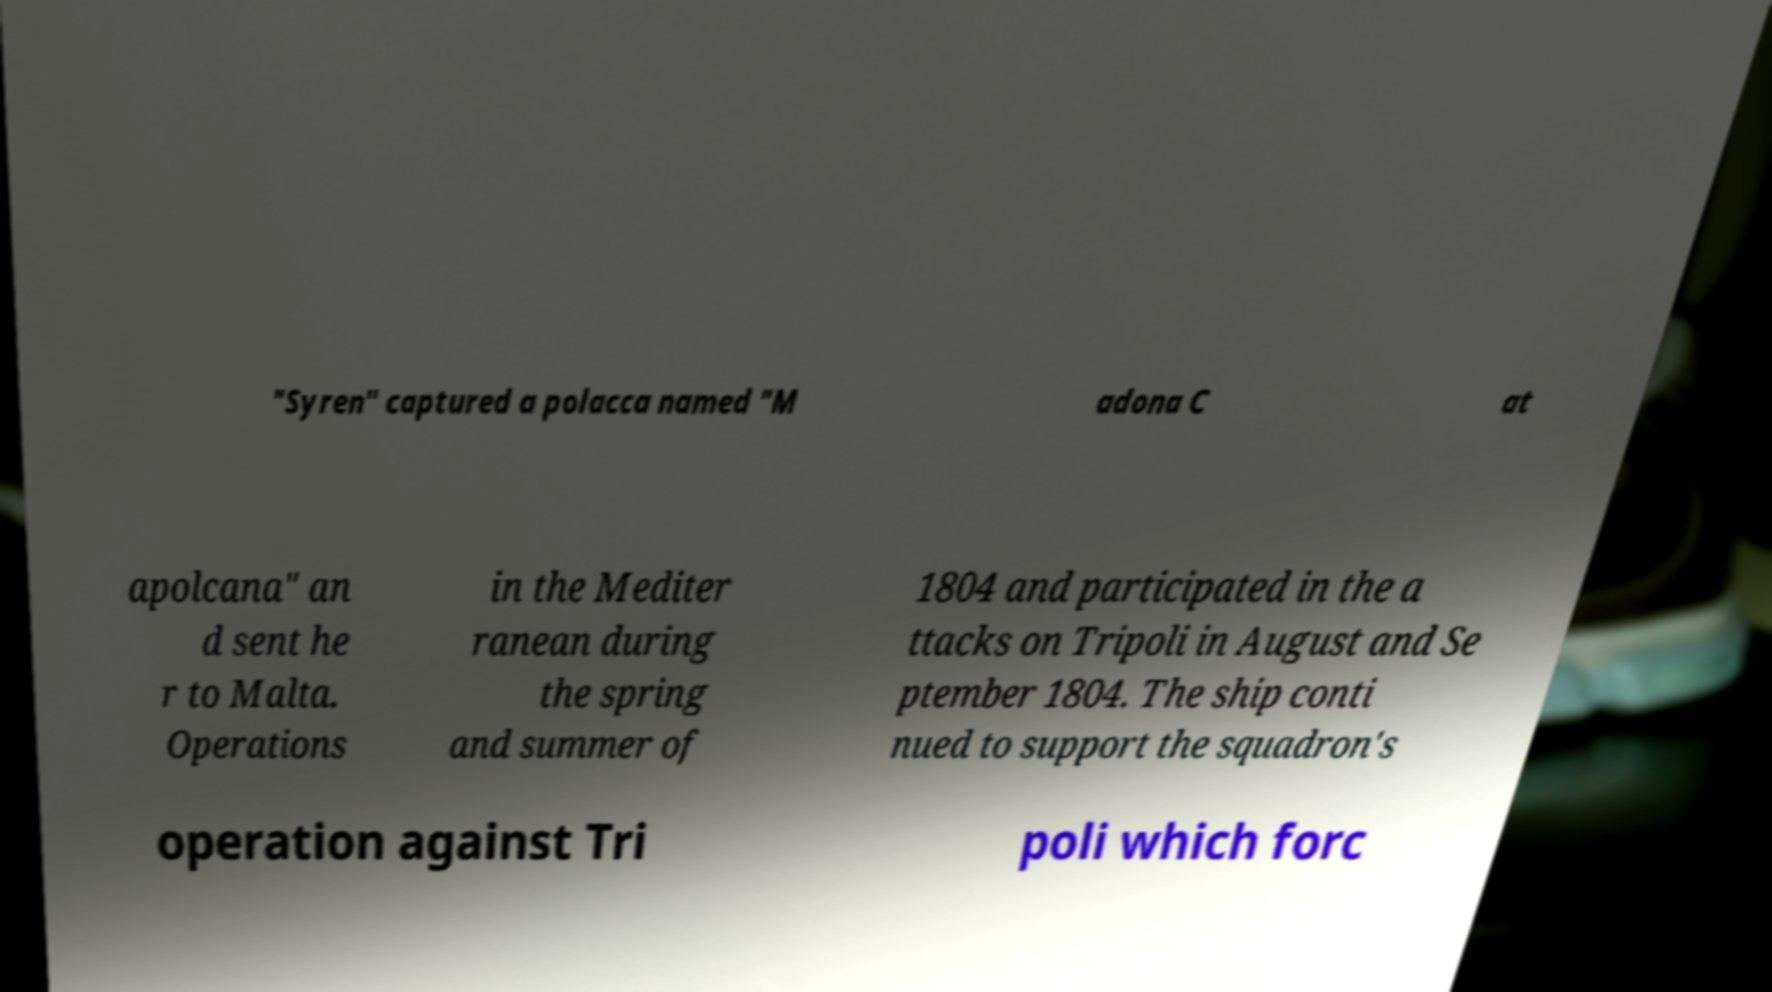I need the written content from this picture converted into text. Can you do that? "Syren" captured a polacca named "M adona C at apolcana" an d sent he r to Malta. Operations in the Mediter ranean during the spring and summer of 1804 and participated in the a ttacks on Tripoli in August and Se ptember 1804. The ship conti nued to support the squadron's operation against Tri poli which forc 